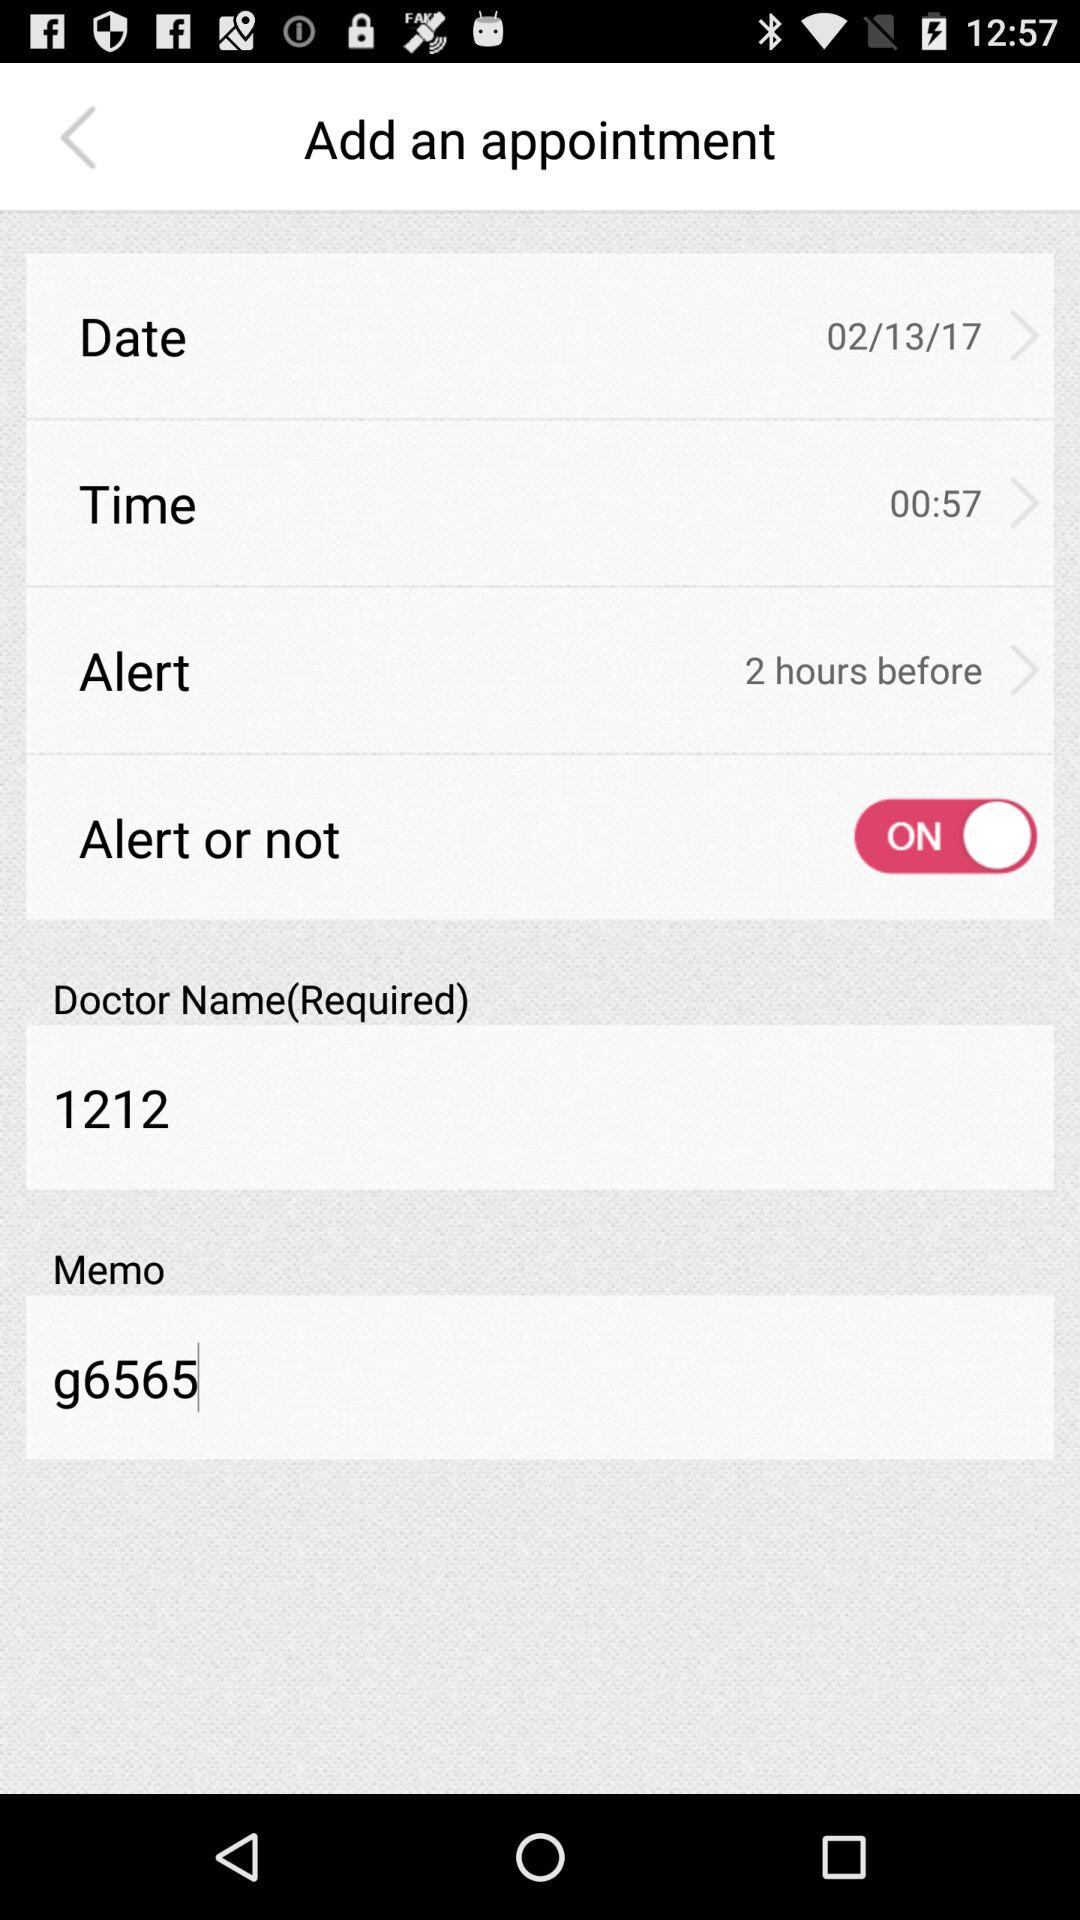What is the name of the doctor? The doctor's name is "1212". 